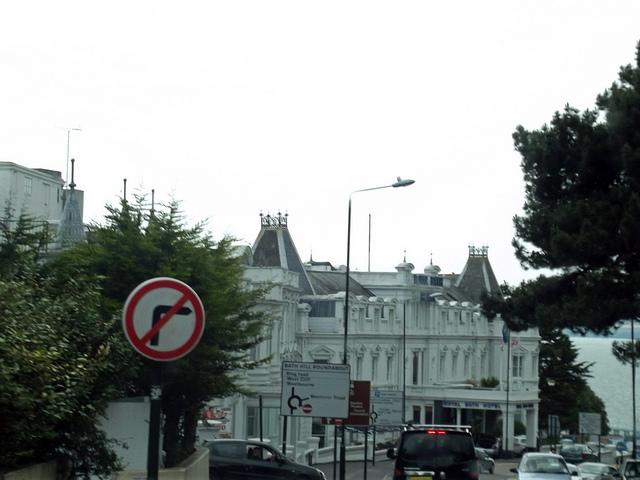What pedal does the driver of the black van have their foot on? Please explain your reasoning. brake. The black van's red lights are on, showing those behind it that the van is stopped or slowing. 